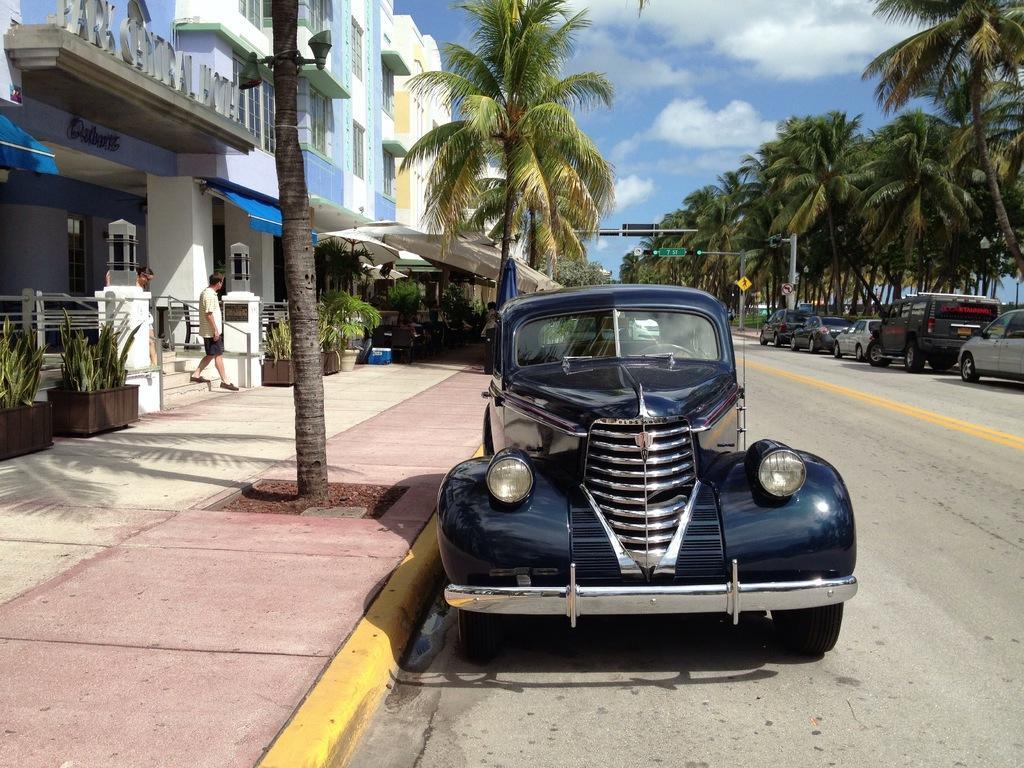Could you give a brief overview of what you see in this image? In this picture there are vehicles on the road and there are buildings and trees and there are poles. On the left side of the image there are two persons walking and there are plants and there is a board on the wall and there is text on the building and there are tents on the footpath. At the top there is sky and there are clouds. At the bottom there is a road. 